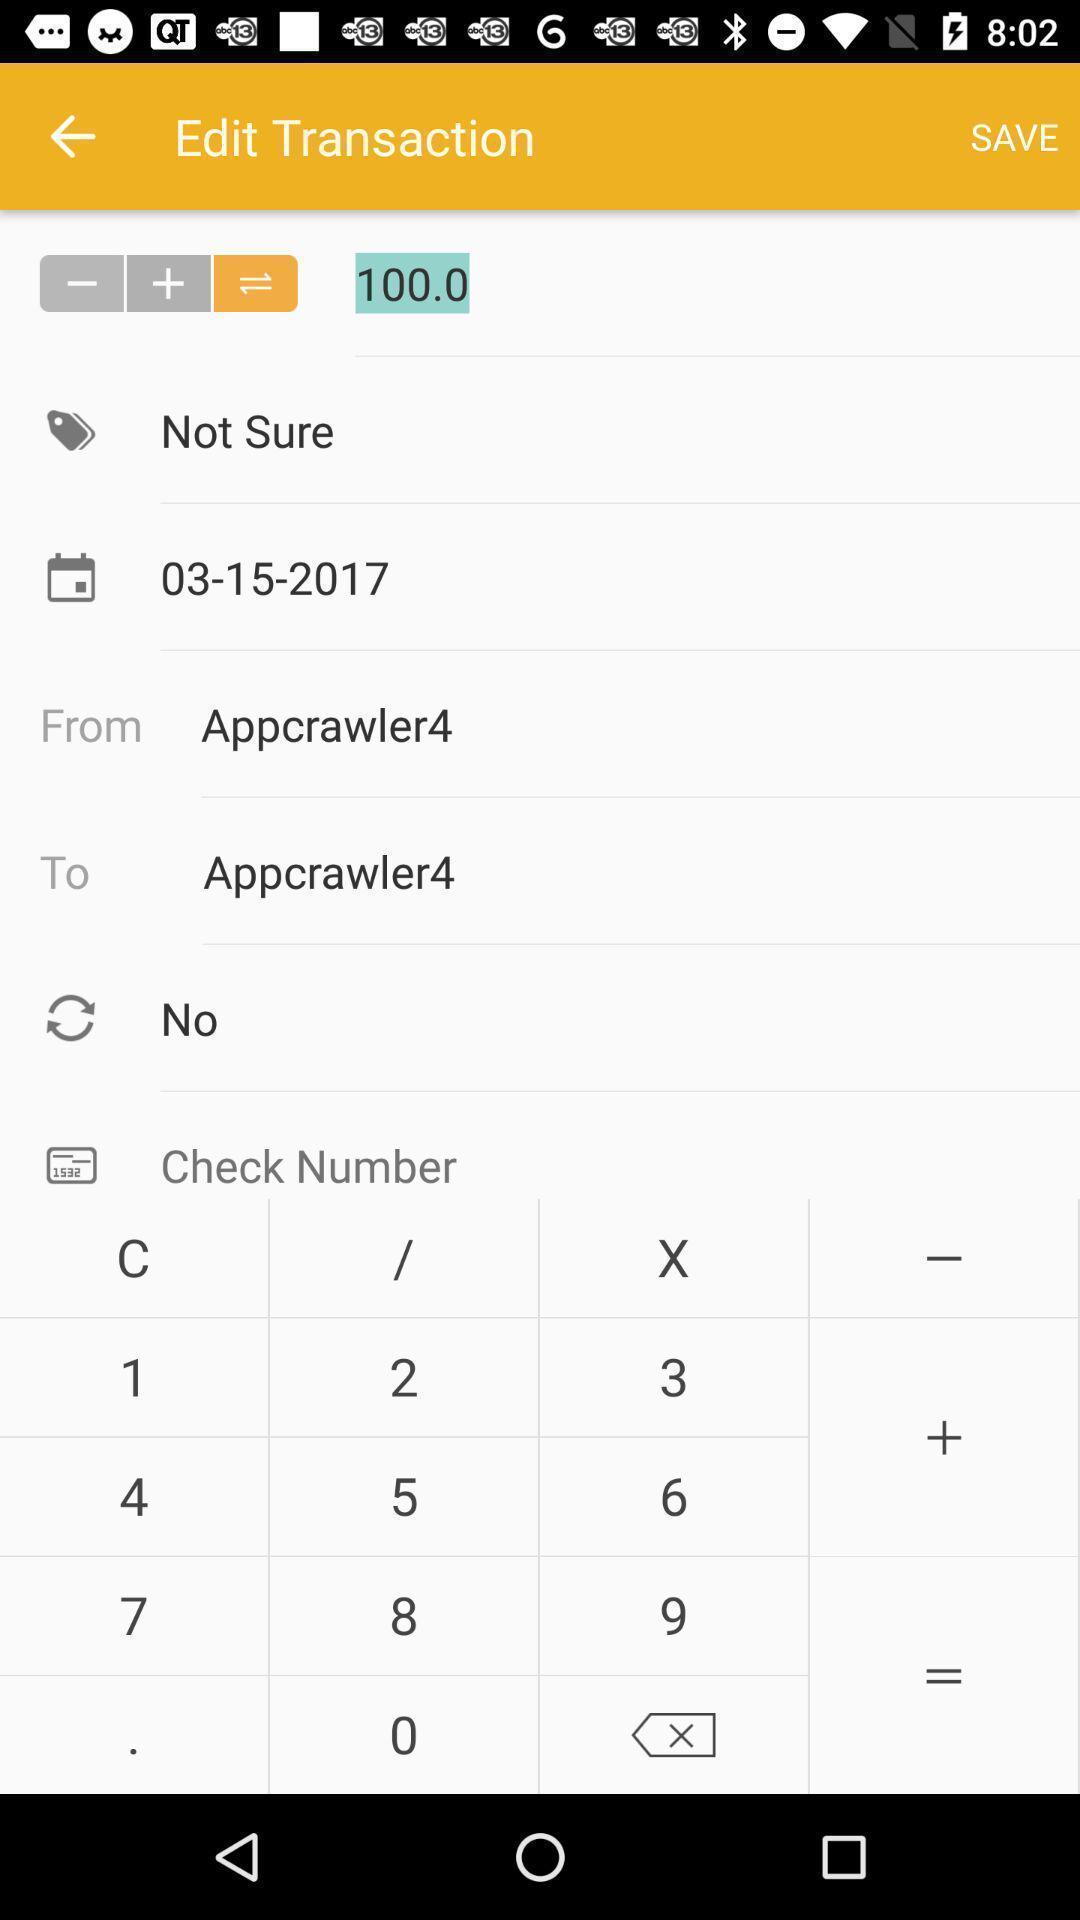Tell me what you see in this picture. Page showing information to edit transaction. 